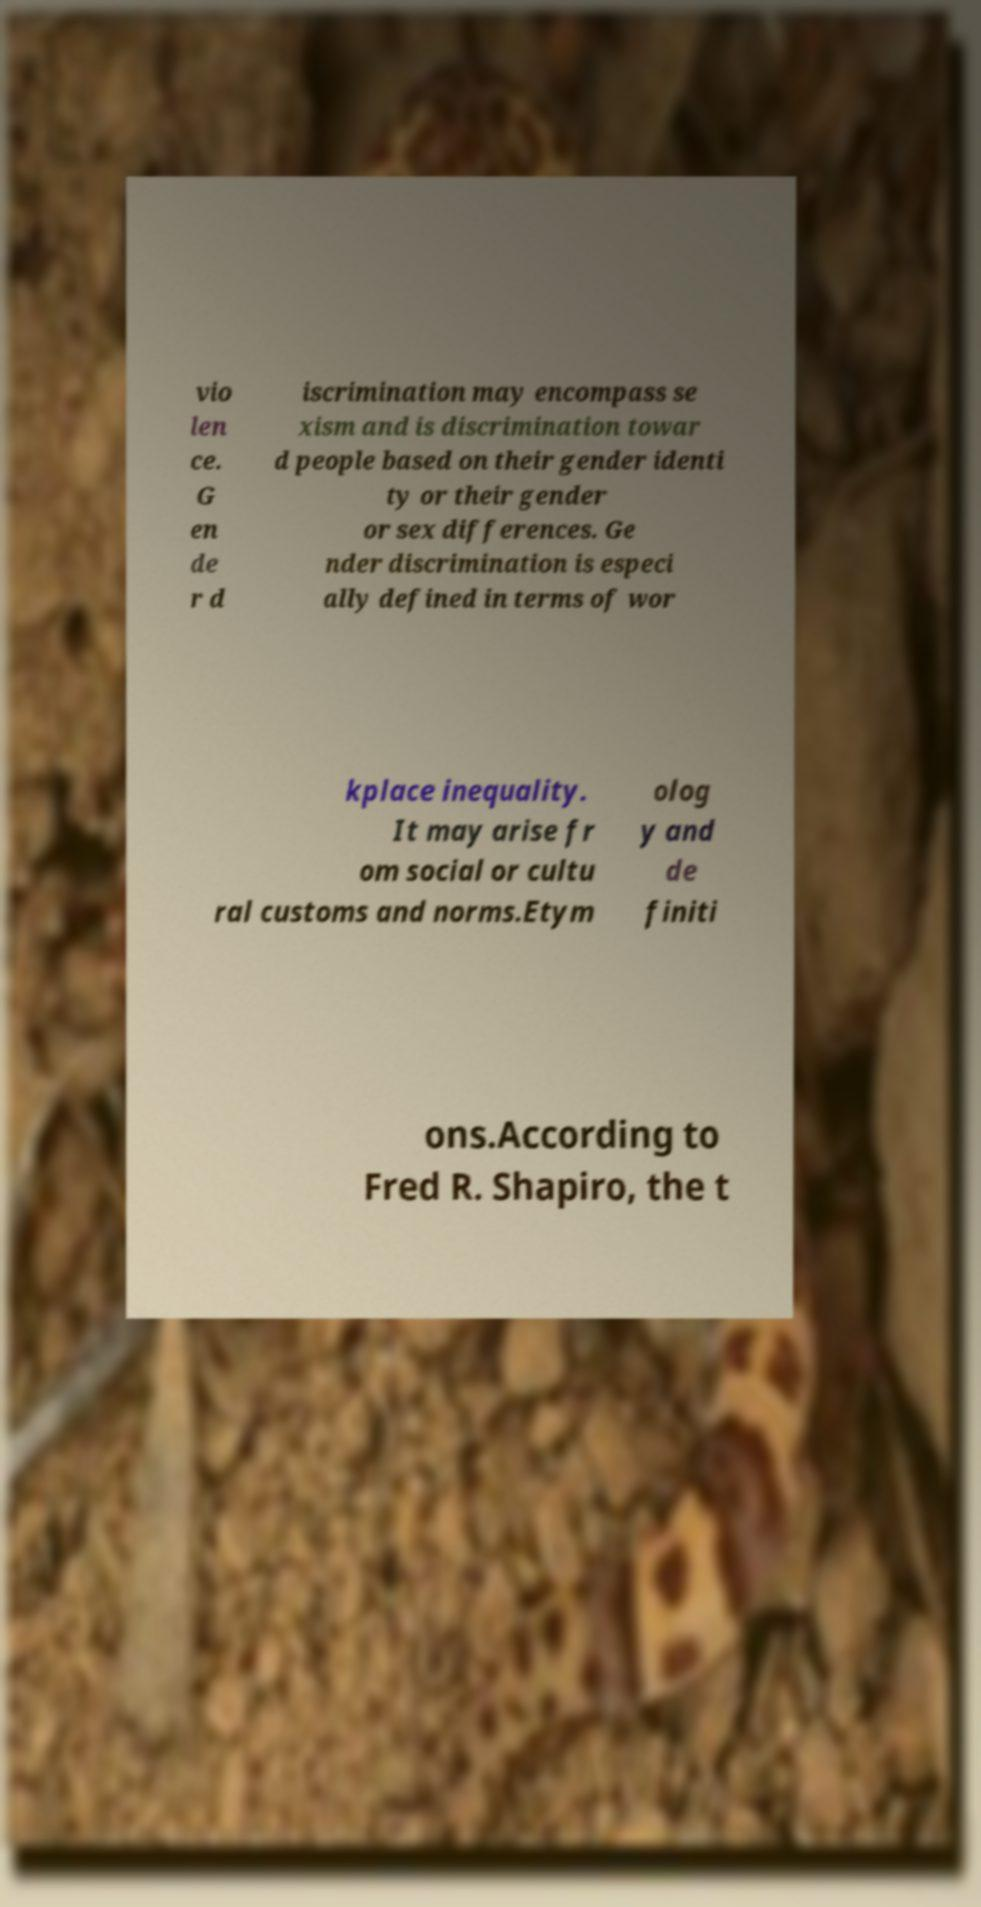Could you extract and type out the text from this image? vio len ce. G en de r d iscrimination may encompass se xism and is discrimination towar d people based on their gender identi ty or their gender or sex differences. Ge nder discrimination is especi ally defined in terms of wor kplace inequality. It may arise fr om social or cultu ral customs and norms.Etym olog y and de finiti ons.According to Fred R. Shapiro, the t 